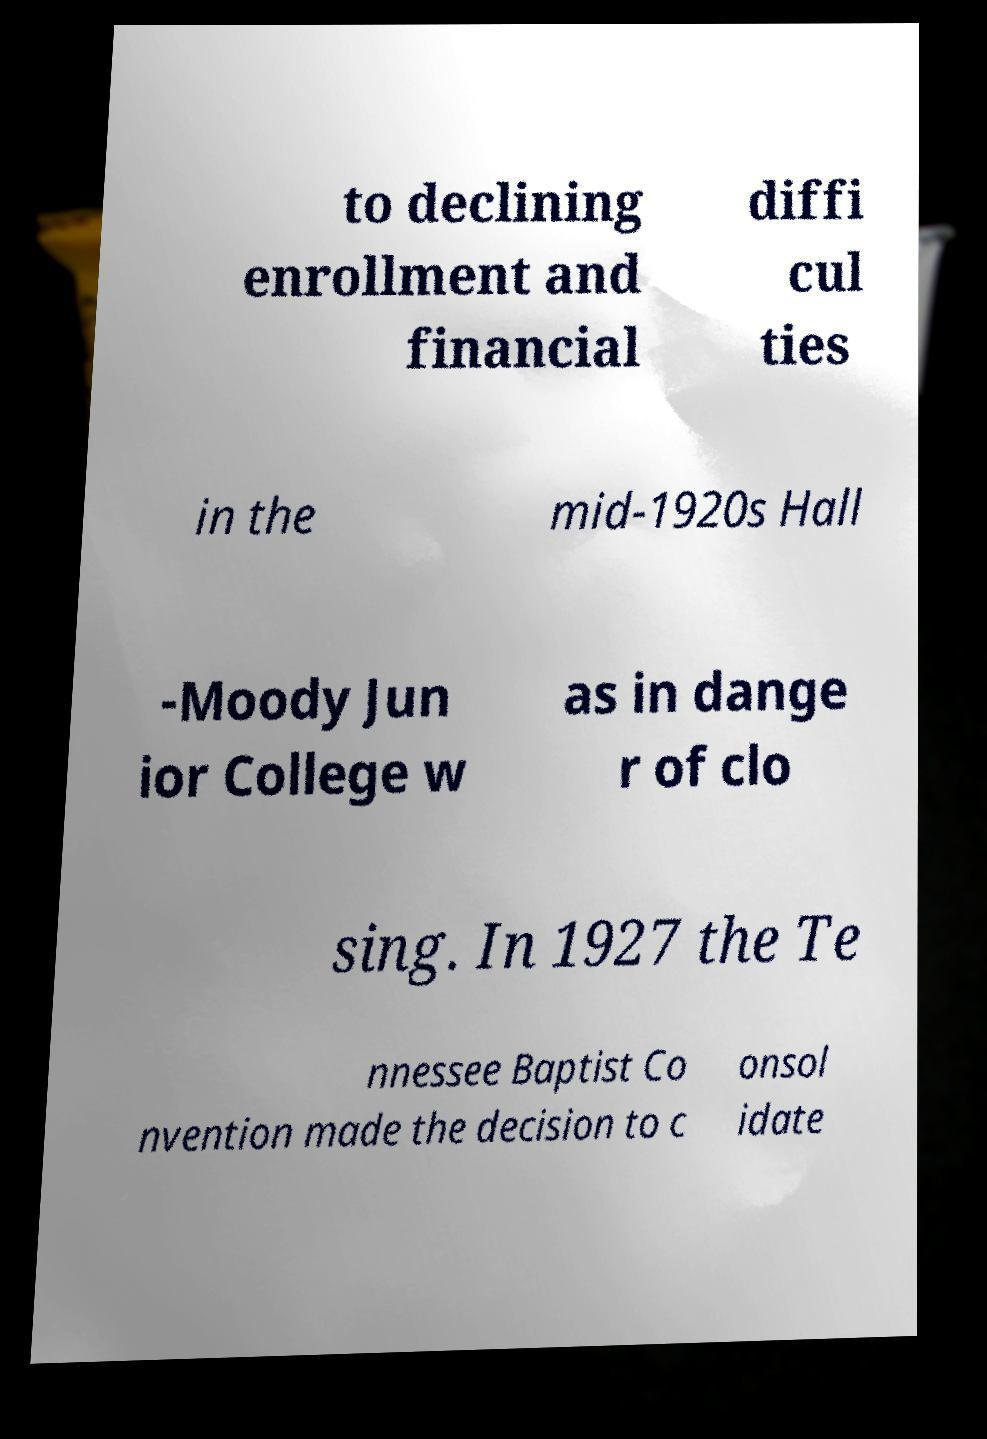For documentation purposes, I need the text within this image transcribed. Could you provide that? to declining enrollment and financial diffi cul ties in the mid-1920s Hall -Moody Jun ior College w as in dange r of clo sing. In 1927 the Te nnessee Baptist Co nvention made the decision to c onsol idate 